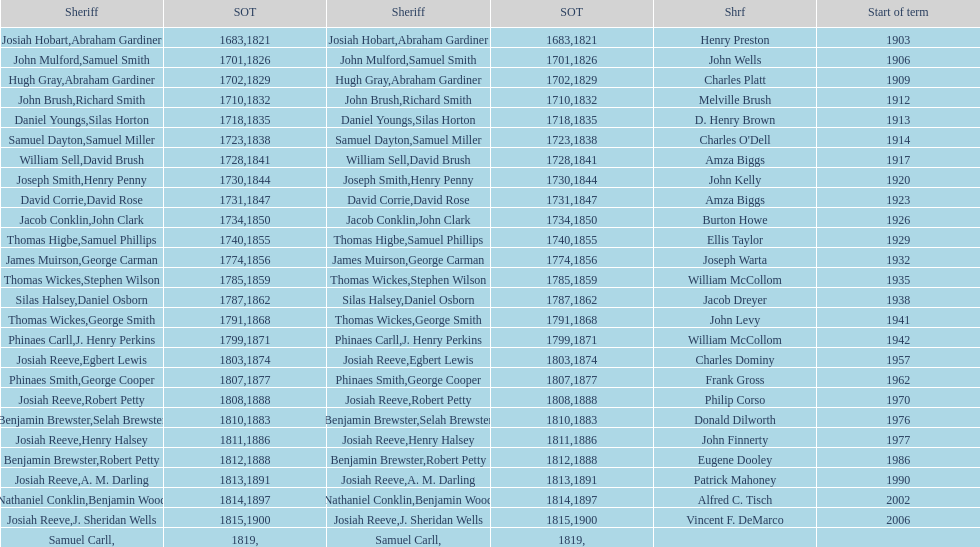Who was the sheriff in suffolk county before amza biggs first term there as sheriff? Charles O'Dell. 